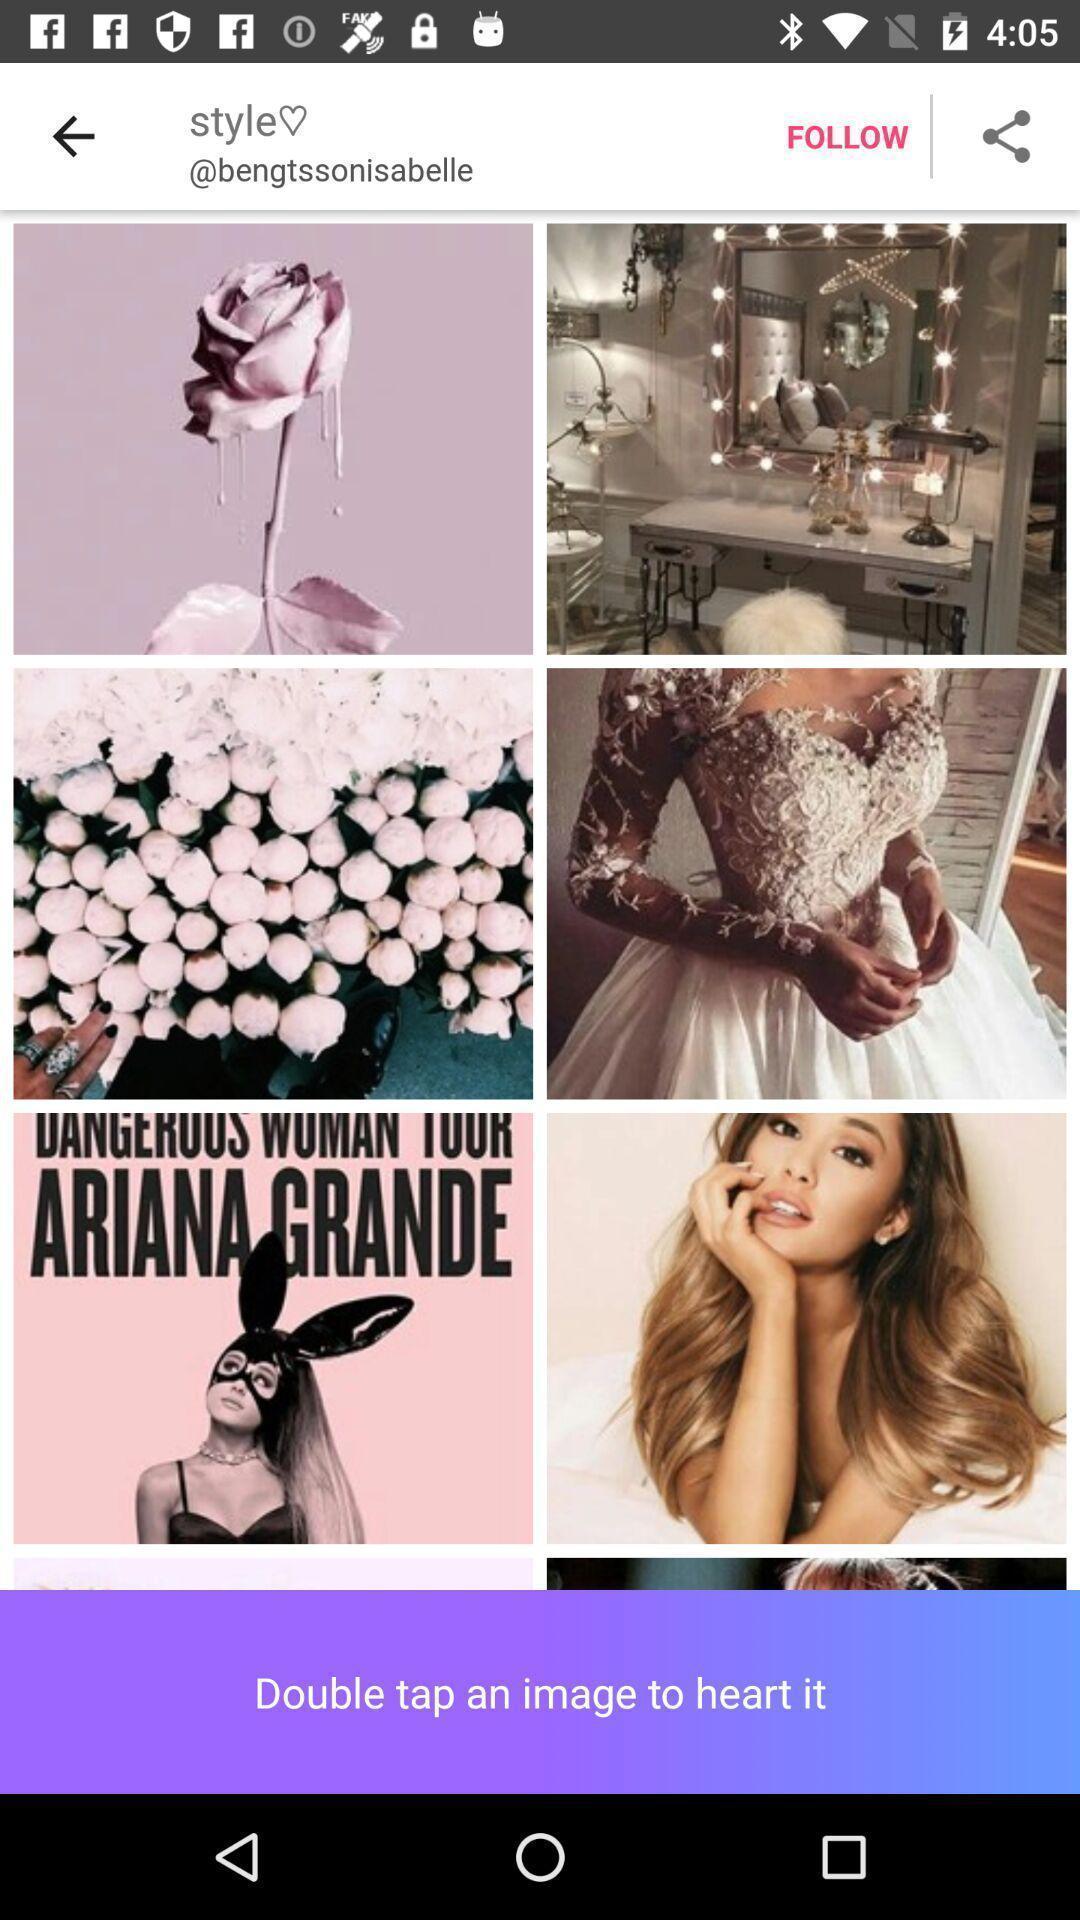Give me a summary of this screen capture. Page showing different images. 